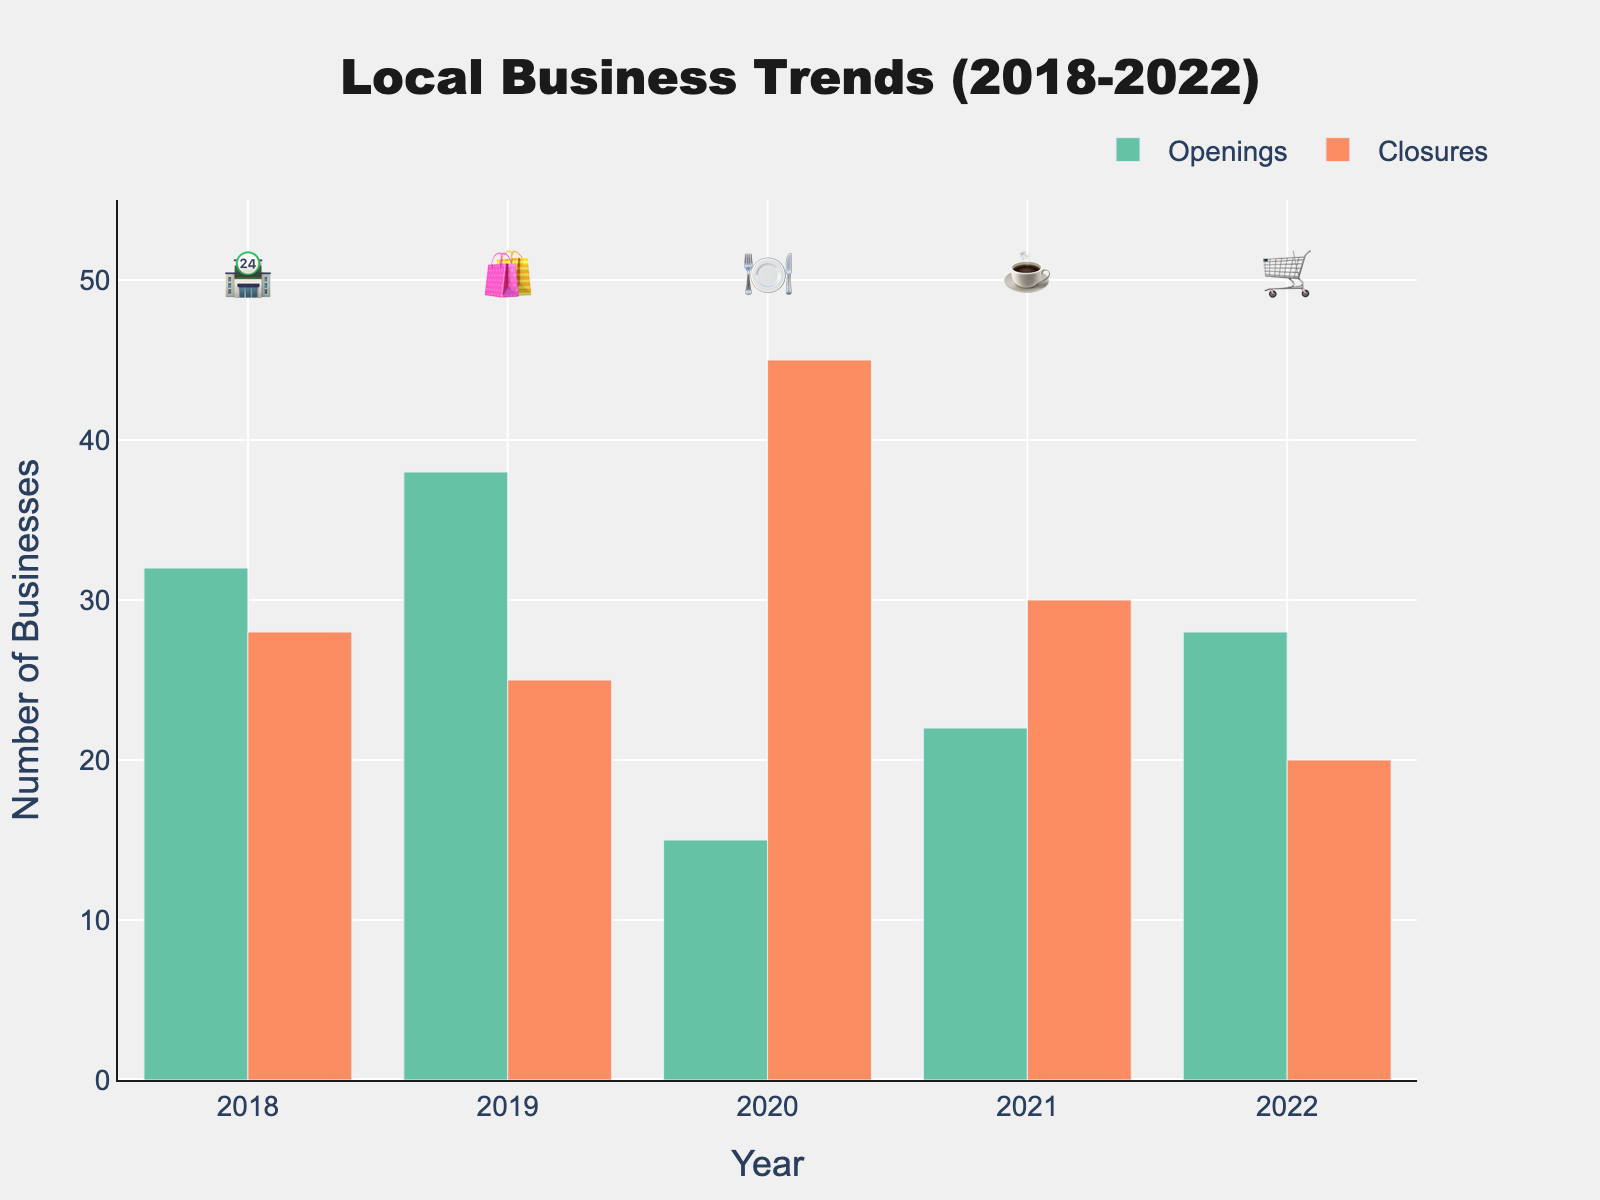What's the title of the chart? The title of the chart is displayed at the top of the figure and is clearly marked.
Answer: Local Business Trends (2018-2022) How many businesses opened in 2018? Look at the bar corresponding to 2018 in the "Openings" category.
Answer: 32 In which year did the most businesses close? Compare the heights of the bars in the "Closures" category across all years.
Answer: 2020 Which year saw the biggest difference between openings and closures? Calculate the difference (Openings - Closures) for each year and compare.
Answer: 2020 What emoji is used for 2021? Look at the scatter trace text at the highest position corresponding to the year 2021.
Answer: ☕ What was the overall trend in openings from 2018 to 2022? Observe the pattern in the "Openings" bars over the years, noting increases and decreases.
Answer: Fluctuating with no clear consistent trend Which year had more closures than openings? Identify the years where the "Closures" bar is taller than the "Openings" bar.
Answer: 2020 How many businesses closed in 2019 and 2020 combined? Add the closure numbers for both years: 25 (2019) + 45 (2020).
Answer: 70 Did any year experience a decrease in both openings and closures compared to the previous year? Compare the values of openings and closures sequentially from year to year.
Answer: 2021 By how much did the number of openings increase from 2021 to 2022? Subtract the openings in 2021 from the openings in 2022: 28 - 22.
Answer: 6 